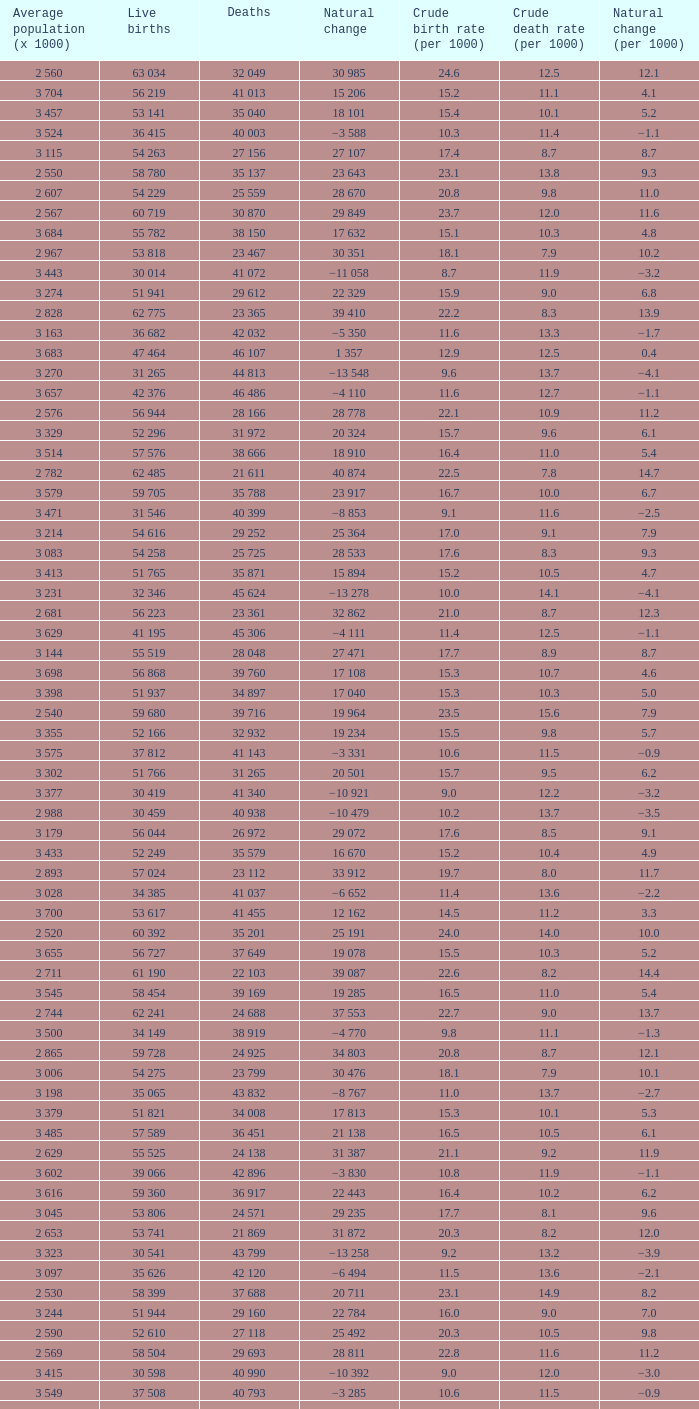Which Live births have a Natural change (per 1000) of 12.0? 53 741. 